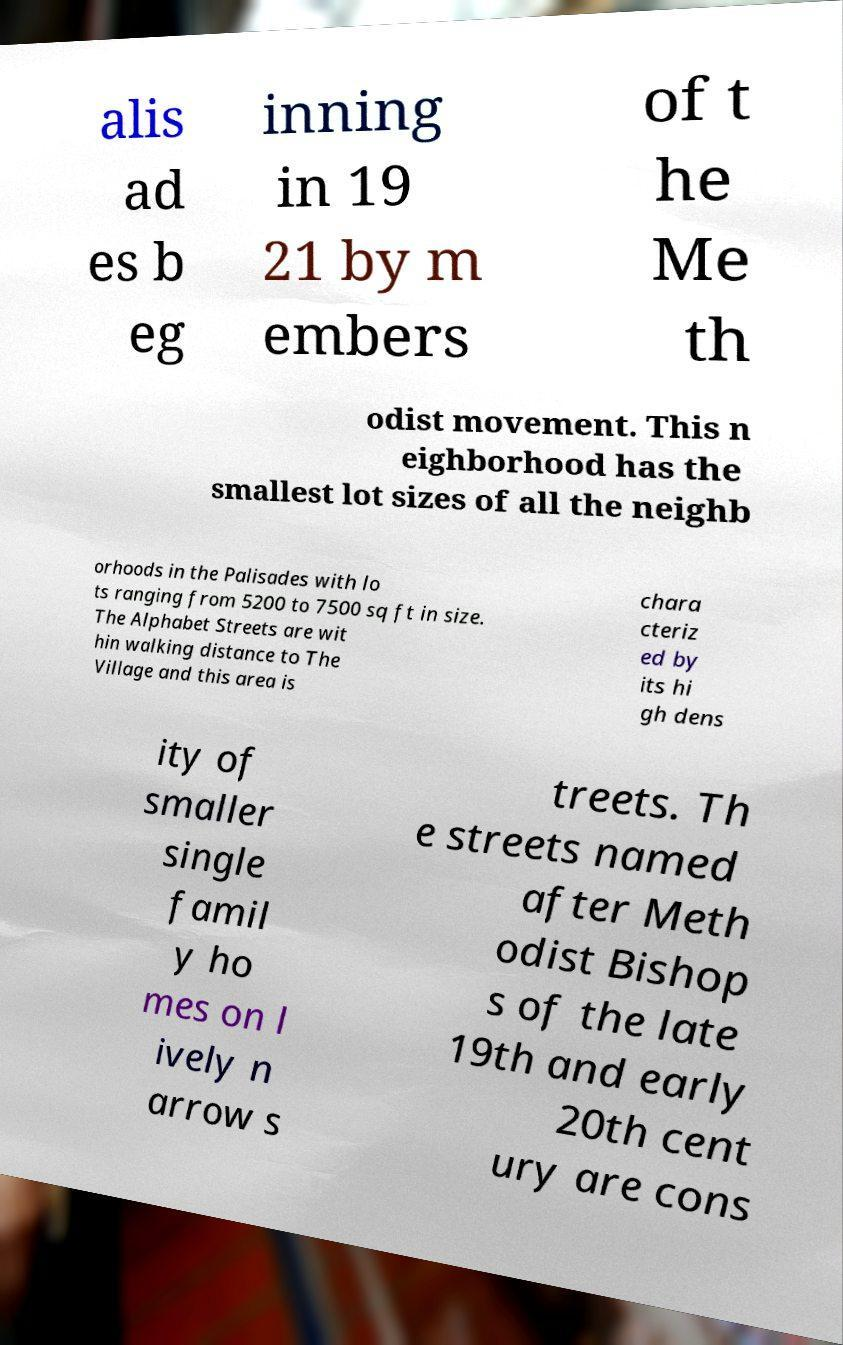I need the written content from this picture converted into text. Can you do that? alis ad es b eg inning in 19 21 by m embers of t he Me th odist movement. This n eighborhood has the smallest lot sizes of all the neighb orhoods in the Palisades with lo ts ranging from 5200 to 7500 sq ft in size. The Alphabet Streets are wit hin walking distance to The Village and this area is chara cteriz ed by its hi gh dens ity of smaller single famil y ho mes on l ively n arrow s treets. Th e streets named after Meth odist Bishop s of the late 19th and early 20th cent ury are cons 